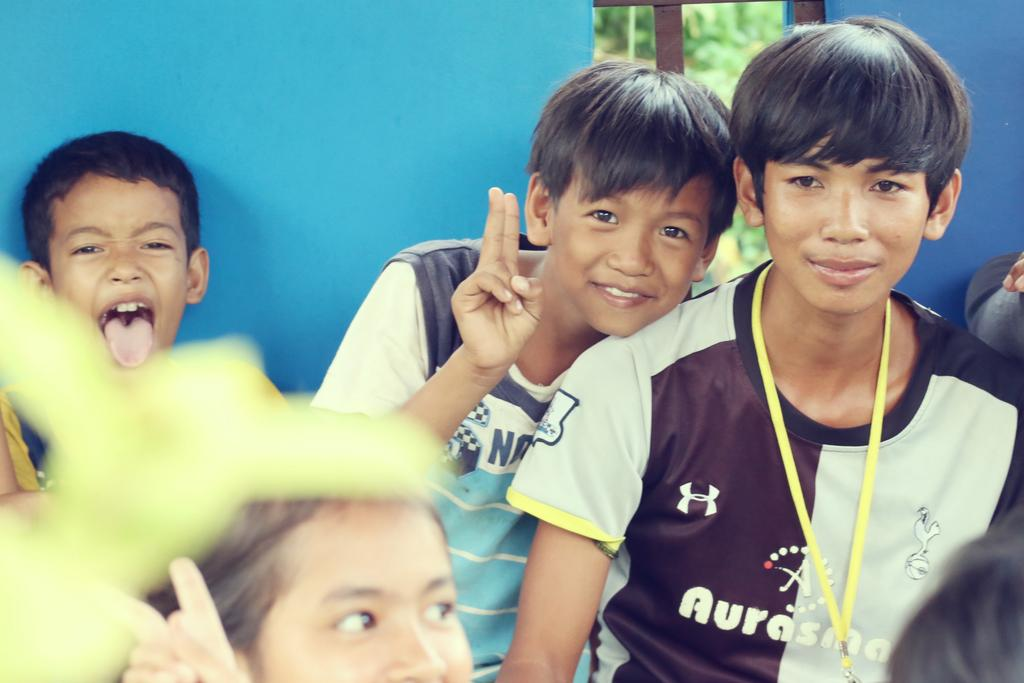<image>
Present a compact description of the photo's key features. A boy with an Aurasma jersey on is with friends 